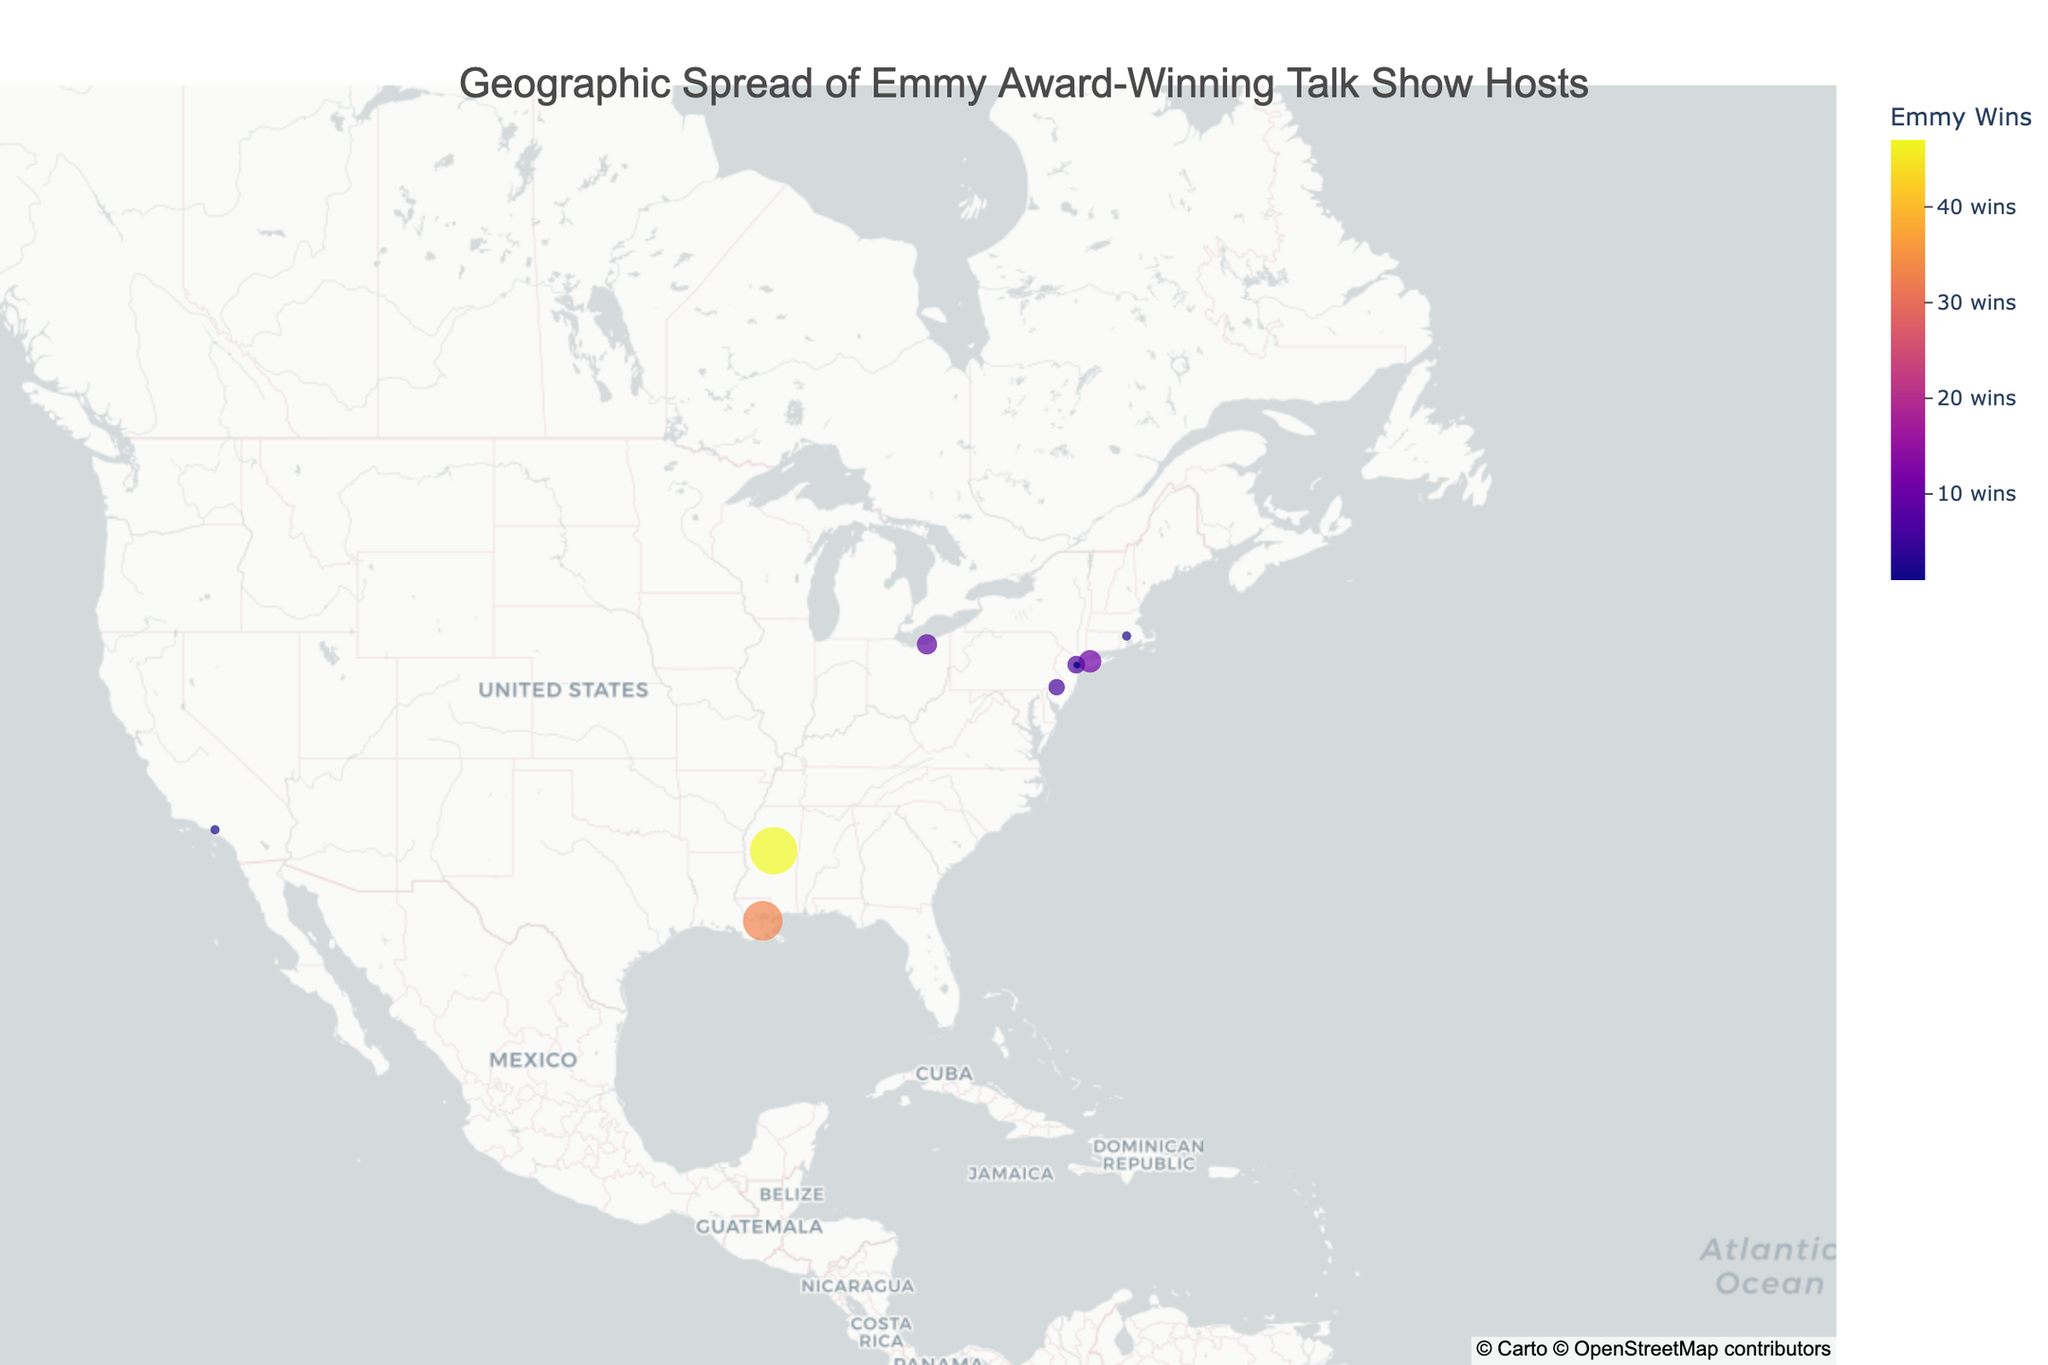What is the title of the geographic plot? The title of the plot is clearly displayed at the top center of the figure.
Answer: Geographic Spread of Emmy Award-Winning Talk Show Hosts Which hometown has the highest number of Emmy wins? Each data point on the plot is represented by a circle, and the size of the circle varies with the number of Emmy wins. The largest circle on the plot represents the highest Emmy wins. Oprah Winfrey's hometown, Kosciusko, MS, has the largest circle.
Answer: Kosciusko, MS How many Emmy wins does Kelly Ripa have? To find the number of Emmy wins for Kelly Ripa, locate her data point on the plot. The hover data provides her hometown, Stratford, NJ, and the number of Emmy wins is listed in the hover text.
Answer: 6 Which host is represented by the data point with 33 Emmy wins? Find the data point with 33 Emmy wins on the plot. The hover text reveals the host's name, which is Ellen DeGeneres.
Answer: Ellen DeGeneres Compare the number of Emmy wins between Regis Philbin and Whoopi Goldberg. Who has more? Locate the data points for Regis Philbin (New York, NY) and Whoopi Goldberg (also New York, NY) on the plot. Compare the number of Emmy wins provided in the hover text. Regis Philbin has 7 Emmy wins while Whoopi Goldberg has 1.
Answer: Regis Philbin How many hometowns of Emmy-award winning hosts are visible on the map? Count each unique hometown represented by a data point on the plot. There are data points for different hometowns.
Answer: 10 What is the average number of Emmy wins for the hosts from New York, NY? There are two hosts from New York, NY: Regis Philbin and Whoopi Goldberg. Sum their Emmy wins (7 + 1 = 8) and divide by the number of hosts (2). 8 / 2 = 4.
Answer: 4 Which hometown is located furthest south on the map? The latitude values on the plot show the vertical position. The hometown with the lowest latitude value is Metairie, LA (29.9841).
Answer: Metairie, LA Identify the two hosts from New York, NY, and their combined Emmy wins. The plot shows two data points for New York, NY. Using the hover text, the hosts are Regis Philbin and Whoopi Goldberg. Their Emmy wins are 7 and 1 respectively. Combined Emmy wins are 7 + 1 = 8.
Answer: Regis Philbin and Whoopi Goldberg, 8 Which host's hometown is closest to the geographic center of the contiguous United States? Identify data points that are roughly in the central region of the map. Cleveland, OH (Phil Donahue) is quite central on the plot.
Answer: Phil Donahue (Cleveland, OH) 